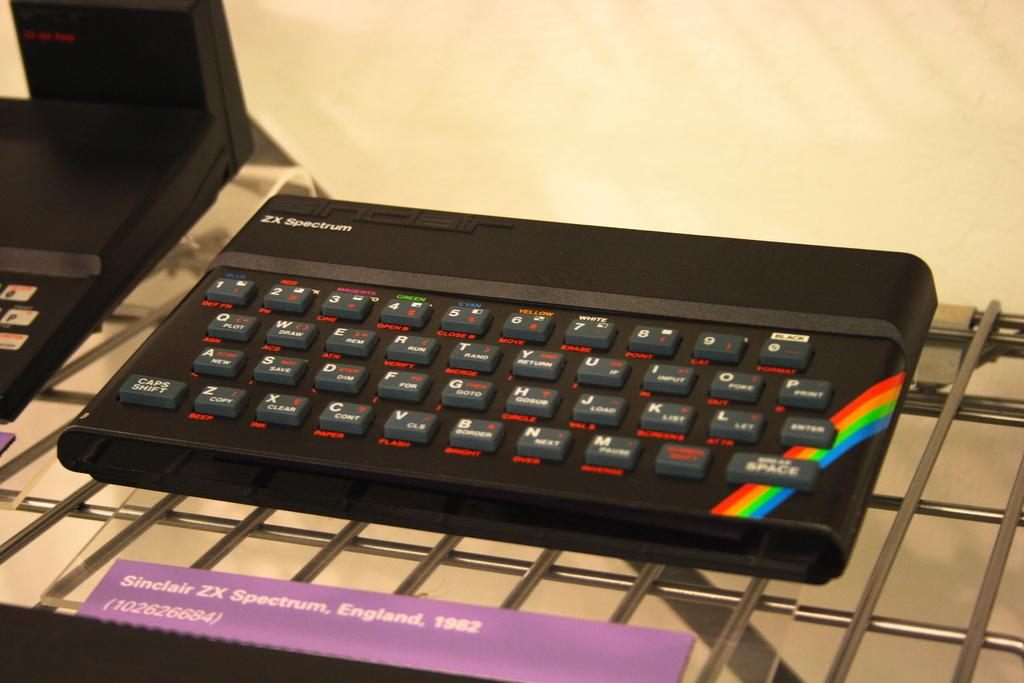<image>
Create a compact narrative representing the image presented. A small electronic device called a Sinclair ZX Spectrum from 1982. 